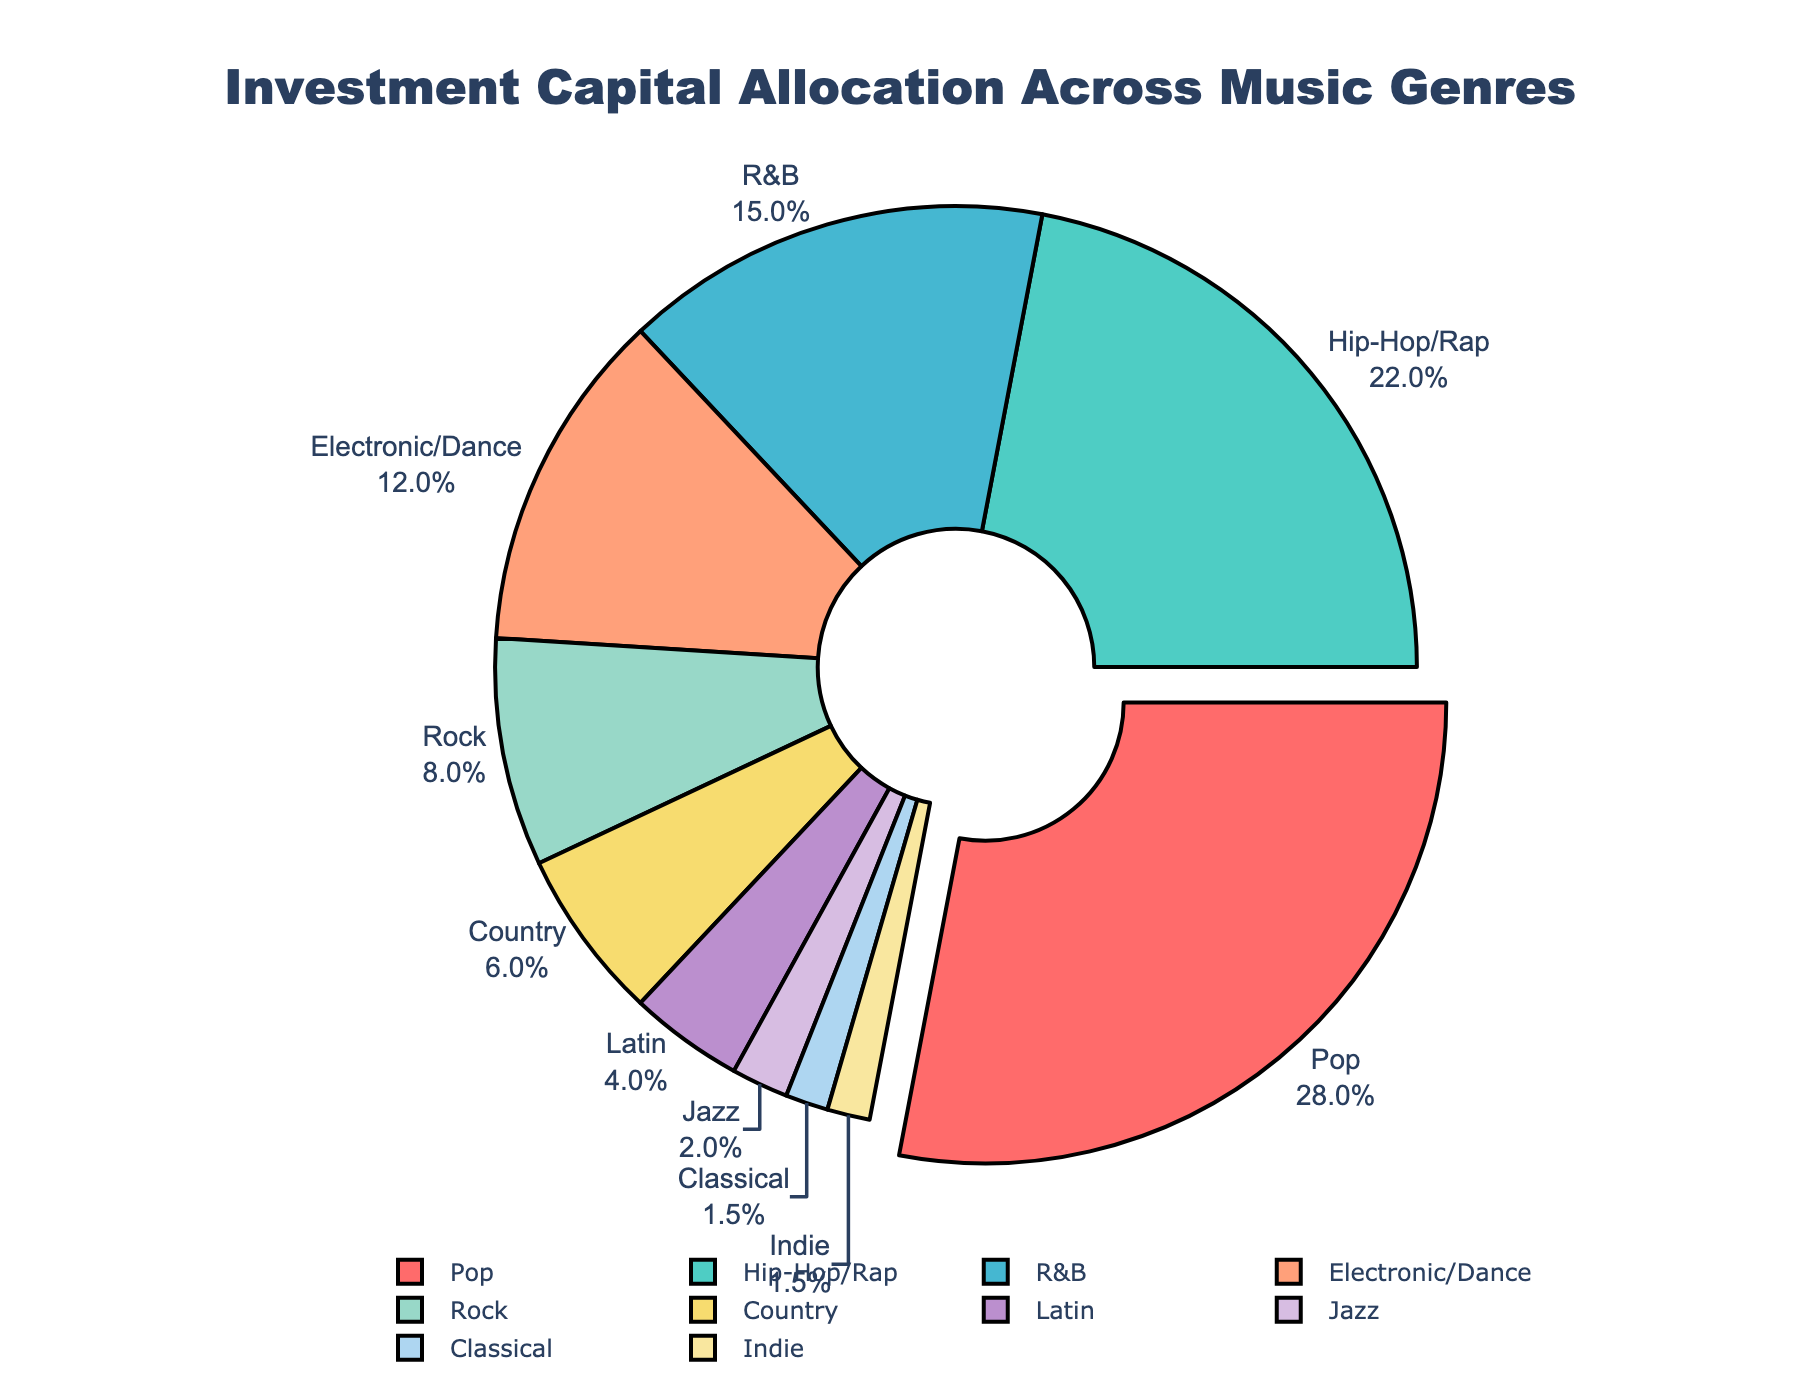Which genre has the highest allocation of investment capital? The genre with the highest percentage slice in the pie chart is Pop.
Answer: Pop What is the combined percentage allocation for Rock and Jazz? The percentages for Rock and Jazz are 8 and 2, respectively. Adding them up gives 8 + 2 = 10.
Answer: 10 Is the investment in Hip-Hop/Rap greater than in Electronic/Dance? From the chart, Hip-Hop/Rap has 22% while Electronic/Dance has 12%. 22% is indeed greater than 12%.
Answer: Yes How does the investment in Classical music compare to that in Indie music? Both Classical and Indie music have the same allocation, which is 1.5%.
Answer: They are equal Which genre has the smallest allocation of investment capital? The smallest slice of the pie chart represents the genre with the smallest allocation, which is Classical.
Answer: Classical What is the difference in investment allocation between Pop and Country? The percentage for Pop is 28, and for Country, it is 6. The difference is 28 - 6 = 22.
Answer: 22 What percentage of the total investment is allocated to genres other than Pop, Hip-Hop/Rap, and R&B? Summing up the percentages for Pop, Hip-Hop/Rap, and R&B gives 28 + 22 + 15 = 65. The remaining allocation is 100 - 65 = 35.
Answer: 35 What is the total percentage allocation for genres with less than 10% investment? The genres with less than 10% are Rock (8), Country (6), Latin (4), Jazz (2), Classical (1.5), and Indie (1.5). Adding these, we get 8 + 6 + 4 + 2 + 1.5 + 1.5 = 23.
Answer: 23 Are there more genres allocated 5% or less investment than those allocated more than 10%? Genres with 5% or less: Latin (4), Jazz (2), Classical (1.5), Indie (1.5) = 4 genres. Genres with more than 10%: Pop (28), Hip-Hop/Rap (22), R&B (15), Electronic/Dance (12) = 4 genres. There are equal numbers of genres in both categories.
Answer: No 